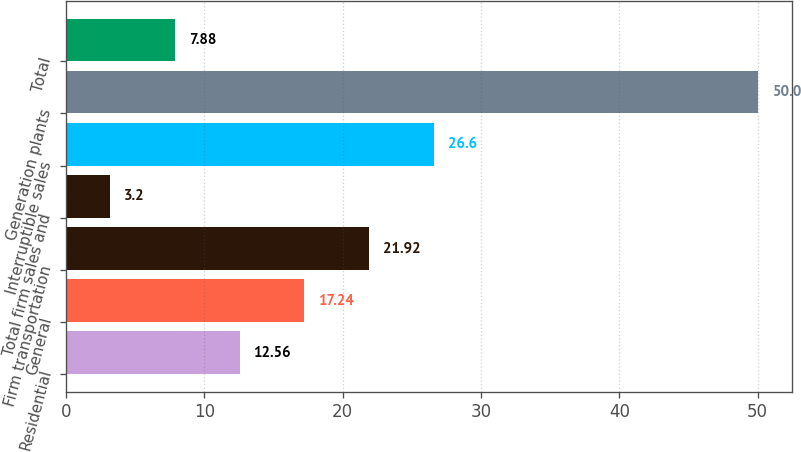<chart> <loc_0><loc_0><loc_500><loc_500><bar_chart><fcel>Residential<fcel>General<fcel>Firm transportation<fcel>Total firm sales and<fcel>Interruptible sales<fcel>Generation plants<fcel>Total<nl><fcel>12.56<fcel>17.24<fcel>21.92<fcel>3.2<fcel>26.6<fcel>50<fcel>7.88<nl></chart> 